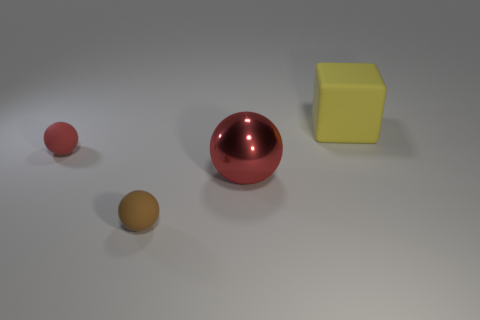What size is the matte object on the right side of the big object that is to the left of the big yellow rubber block?
Provide a short and direct response. Large. Are there an equal number of rubber things that are left of the cube and large red metal spheres that are behind the small red thing?
Provide a succinct answer. No. There is a big metal thing that is the same shape as the tiny red thing; what color is it?
Offer a very short reply. Red. What number of other large blocks are the same color as the big block?
Your response must be concise. 0. Does the metal object that is behind the brown rubber object have the same shape as the yellow rubber thing?
Offer a terse response. No. There is a tiny object that is behind the big object on the left side of the big thing that is on the right side of the large red metal thing; what shape is it?
Provide a short and direct response. Sphere. The brown object has what size?
Make the answer very short. Small. What color is the small ball that is made of the same material as the brown thing?
Make the answer very short. Red. How many big red balls are made of the same material as the big yellow object?
Your answer should be compact. 0. There is a big metallic ball; is its color the same as the small ball in front of the large metal object?
Your answer should be very brief. No. 